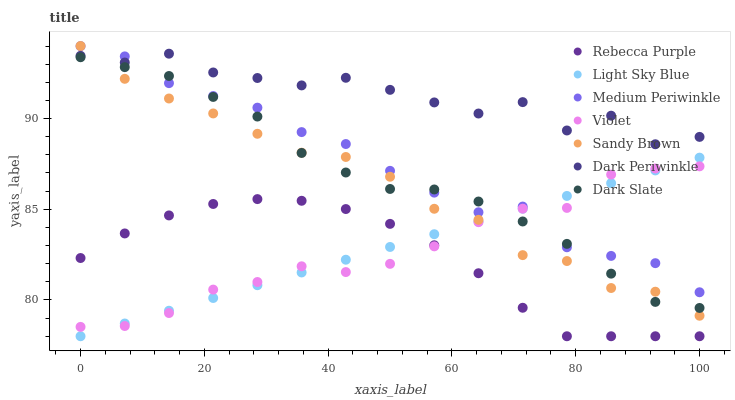Does Rebecca Purple have the minimum area under the curve?
Answer yes or no. Yes. Does Dark Periwinkle have the maximum area under the curve?
Answer yes or no. Yes. Does Dark Slate have the minimum area under the curve?
Answer yes or no. No. Does Dark Slate have the maximum area under the curve?
Answer yes or no. No. Is Light Sky Blue the smoothest?
Answer yes or no. Yes. Is Dark Periwinkle the roughest?
Answer yes or no. Yes. Is Dark Slate the smoothest?
Answer yes or no. No. Is Dark Slate the roughest?
Answer yes or no. No. Does Light Sky Blue have the lowest value?
Answer yes or no. Yes. Does Dark Slate have the lowest value?
Answer yes or no. No. Does Sandy Brown have the highest value?
Answer yes or no. Yes. Does Dark Slate have the highest value?
Answer yes or no. No. Is Dark Slate less than Dark Periwinkle?
Answer yes or no. Yes. Is Medium Periwinkle greater than Rebecca Purple?
Answer yes or no. Yes. Does Sandy Brown intersect Violet?
Answer yes or no. Yes. Is Sandy Brown less than Violet?
Answer yes or no. No. Is Sandy Brown greater than Violet?
Answer yes or no. No. Does Dark Slate intersect Dark Periwinkle?
Answer yes or no. No. 